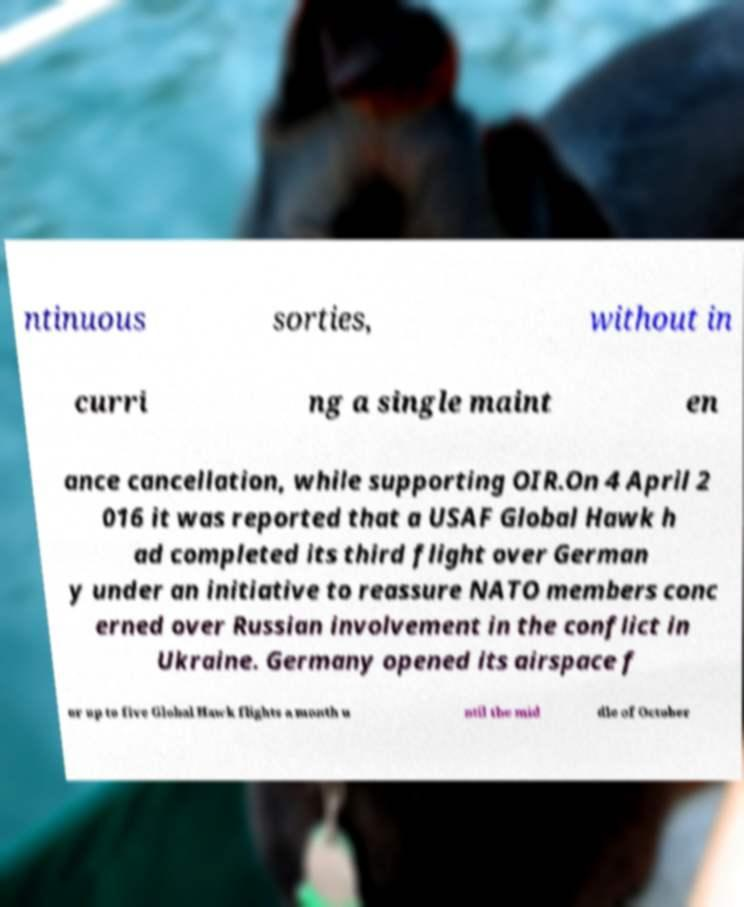I need the written content from this picture converted into text. Can you do that? ntinuous sorties, without in curri ng a single maint en ance cancellation, while supporting OIR.On 4 April 2 016 it was reported that a USAF Global Hawk h ad completed its third flight over German y under an initiative to reassure NATO members conc erned over Russian involvement in the conflict in Ukraine. Germany opened its airspace f or up to five Global Hawk flights a month u ntil the mid dle of October 